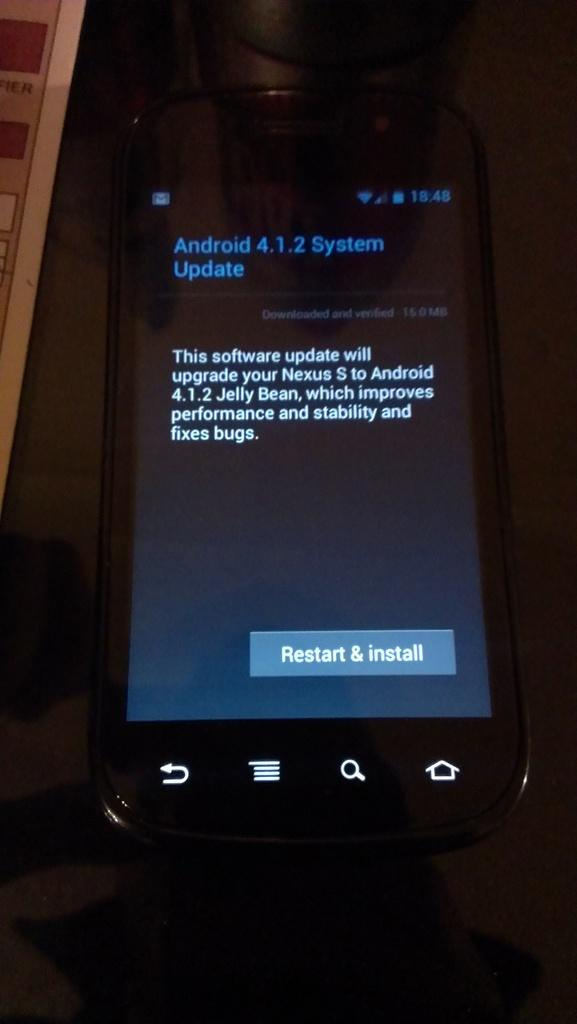<image>
Share a concise interpretation of the image provided. A black smart phone on the restart and install process. 